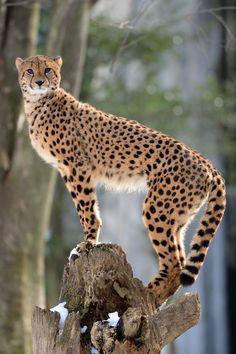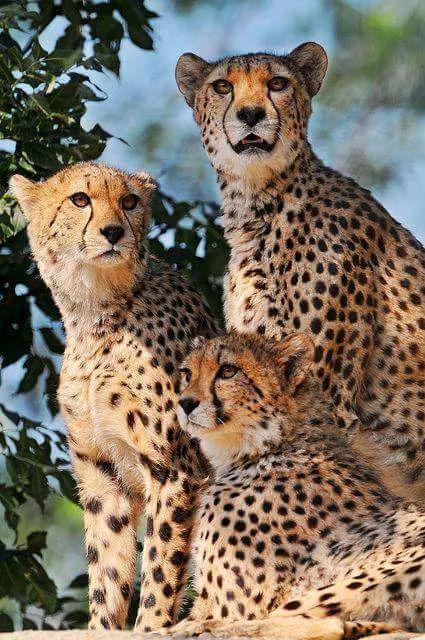The first image is the image on the left, the second image is the image on the right. Assess this claim about the two images: "The left image contains two cheetahs.". Correct or not? Answer yes or no. No. The first image is the image on the left, the second image is the image on the right. Evaluate the accuracy of this statement regarding the images: "A spotted adult wildcat is carrying a dangling kitten in its mouth in one image.". Is it true? Answer yes or no. No. 